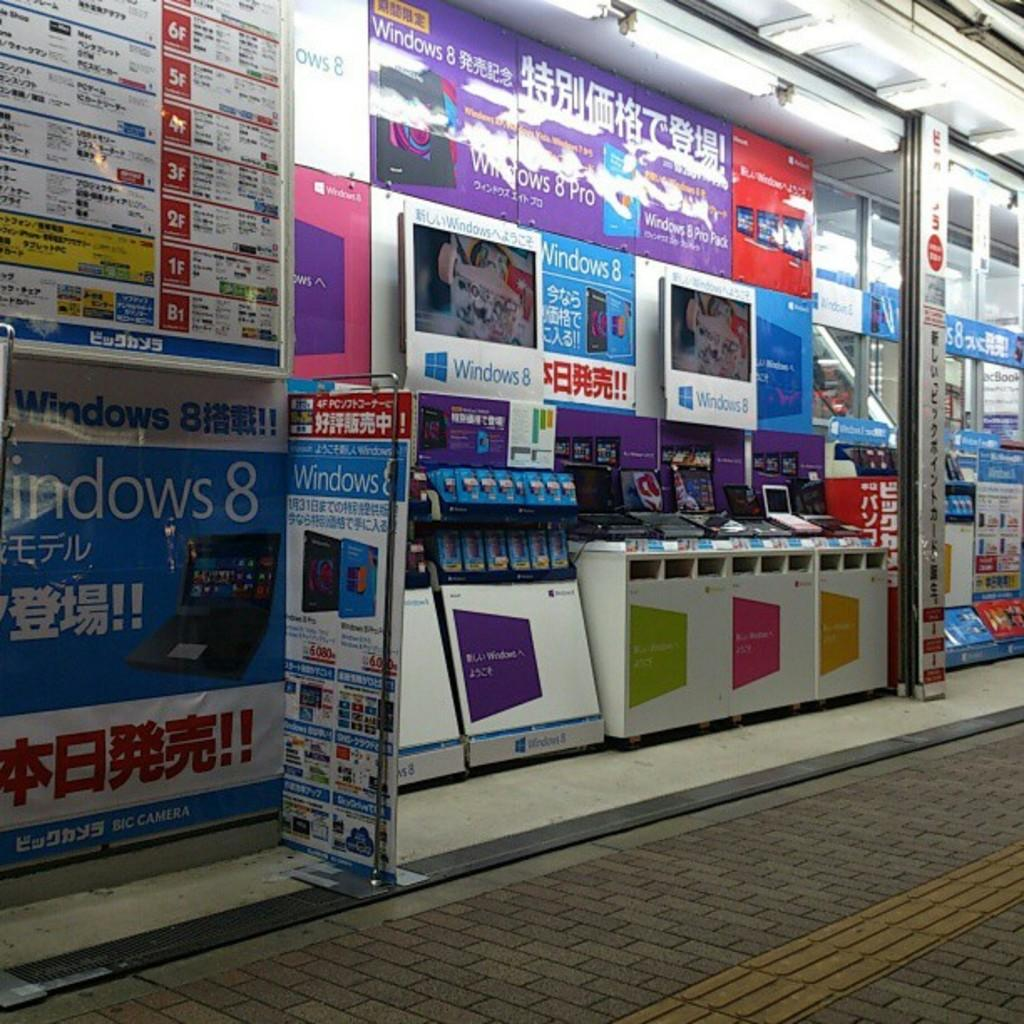<image>
Describe the image concisely. Store front that sells Windows 8 Pro in different colors. 